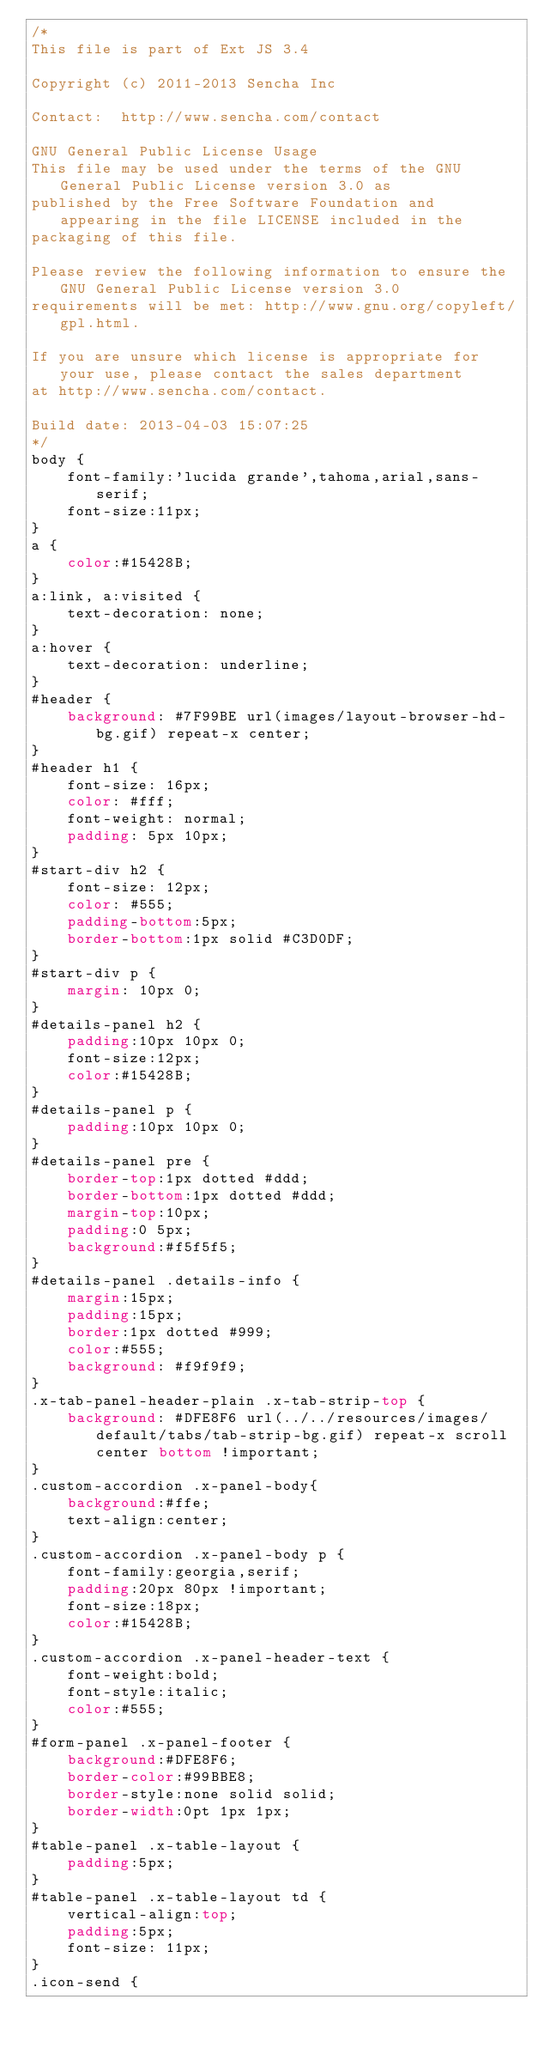Convert code to text. <code><loc_0><loc_0><loc_500><loc_500><_CSS_>/*
This file is part of Ext JS 3.4

Copyright (c) 2011-2013 Sencha Inc

Contact:  http://www.sencha.com/contact

GNU General Public License Usage
This file may be used under the terms of the GNU General Public License version 3.0 as
published by the Free Software Foundation and appearing in the file LICENSE included in the
packaging of this file.

Please review the following information to ensure the GNU General Public License version 3.0
requirements will be met: http://www.gnu.org/copyleft/gpl.html.

If you are unsure which license is appropriate for your use, please contact the sales department
at http://www.sencha.com/contact.

Build date: 2013-04-03 15:07:25
*/
body {
    font-family:'lucida grande',tahoma,arial,sans-serif;
    font-size:11px;
}
a {
    color:#15428B;
}
a:link, a:visited {
    text-decoration: none;
}
a:hover {
    text-decoration: underline;
}
#header {
    background: #7F99BE url(images/layout-browser-hd-bg.gif) repeat-x center;
}
#header h1 {
    font-size: 16px;
    color: #fff;
    font-weight: normal;
    padding: 5px 10px;
}
#start-div h2 {
    font-size: 12px;
    color: #555;
    padding-bottom:5px;
    border-bottom:1px solid #C3D0DF;
}
#start-div p {
    margin: 10px 0;
}
#details-panel h2 {
    padding:10px 10px 0;
    font-size:12px;
    color:#15428B;
}
#details-panel p {
    padding:10px 10px 0;
}
#details-panel pre {
    border-top:1px dotted #ddd;
    border-bottom:1px dotted #ddd;
    margin-top:10px;
    padding:0 5px;
    background:#f5f5f5;
}
#details-panel .details-info {
    margin:15px;
    padding:15px;
    border:1px dotted #999;
    color:#555;
    background: #f9f9f9;
}
.x-tab-panel-header-plain .x-tab-strip-top {
    background: #DFE8F6 url(../../resources/images/default/tabs/tab-strip-bg.gif) repeat-x scroll center bottom !important;
}
.custom-accordion .x-panel-body{
    background:#ffe;
    text-align:center;
}
.custom-accordion .x-panel-body p {
    font-family:georgia,serif;
    padding:20px 80px !important;
    font-size:18px;
    color:#15428B;
}
.custom-accordion .x-panel-header-text {
    font-weight:bold;
    font-style:italic;
    color:#555;
}
#form-panel .x-panel-footer {
    background:#DFE8F6;
    border-color:#99BBE8;
    border-style:none solid solid;
    border-width:0pt 1px 1px;
}
#table-panel .x-table-layout {
    padding:5px;
}
#table-panel .x-table-layout td {
    vertical-align:top;
    padding:5px;
    font-size: 11px;
}
.icon-send {</code> 